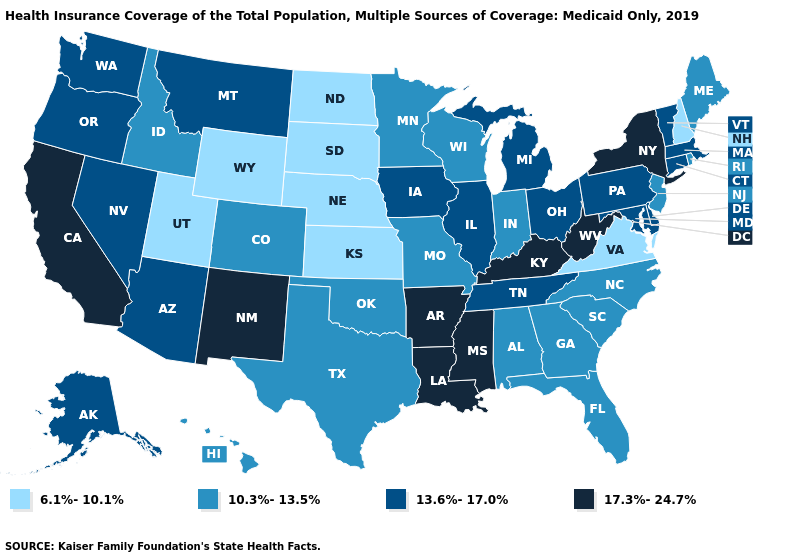Name the states that have a value in the range 13.6%-17.0%?
Quick response, please. Alaska, Arizona, Connecticut, Delaware, Illinois, Iowa, Maryland, Massachusetts, Michigan, Montana, Nevada, Ohio, Oregon, Pennsylvania, Tennessee, Vermont, Washington. Among the states that border Iowa , which have the lowest value?
Keep it brief. Nebraska, South Dakota. What is the value of Florida?
Keep it brief. 10.3%-13.5%. Name the states that have a value in the range 13.6%-17.0%?
Answer briefly. Alaska, Arizona, Connecticut, Delaware, Illinois, Iowa, Maryland, Massachusetts, Michigan, Montana, Nevada, Ohio, Oregon, Pennsylvania, Tennessee, Vermont, Washington. Name the states that have a value in the range 10.3%-13.5%?
Quick response, please. Alabama, Colorado, Florida, Georgia, Hawaii, Idaho, Indiana, Maine, Minnesota, Missouri, New Jersey, North Carolina, Oklahoma, Rhode Island, South Carolina, Texas, Wisconsin. Is the legend a continuous bar?
Short answer required. No. What is the value of Kansas?
Concise answer only. 6.1%-10.1%. What is the value of North Carolina?
Quick response, please. 10.3%-13.5%. Among the states that border California , which have the lowest value?
Be succinct. Arizona, Nevada, Oregon. Does the first symbol in the legend represent the smallest category?
Answer briefly. Yes. Name the states that have a value in the range 6.1%-10.1%?
Be succinct. Kansas, Nebraska, New Hampshire, North Dakota, South Dakota, Utah, Virginia, Wyoming. What is the lowest value in the USA?
Be succinct. 6.1%-10.1%. Name the states that have a value in the range 17.3%-24.7%?
Write a very short answer. Arkansas, California, Kentucky, Louisiana, Mississippi, New Mexico, New York, West Virginia. What is the lowest value in states that border West Virginia?
Be succinct. 6.1%-10.1%. Does Massachusetts have the highest value in the USA?
Give a very brief answer. No. 